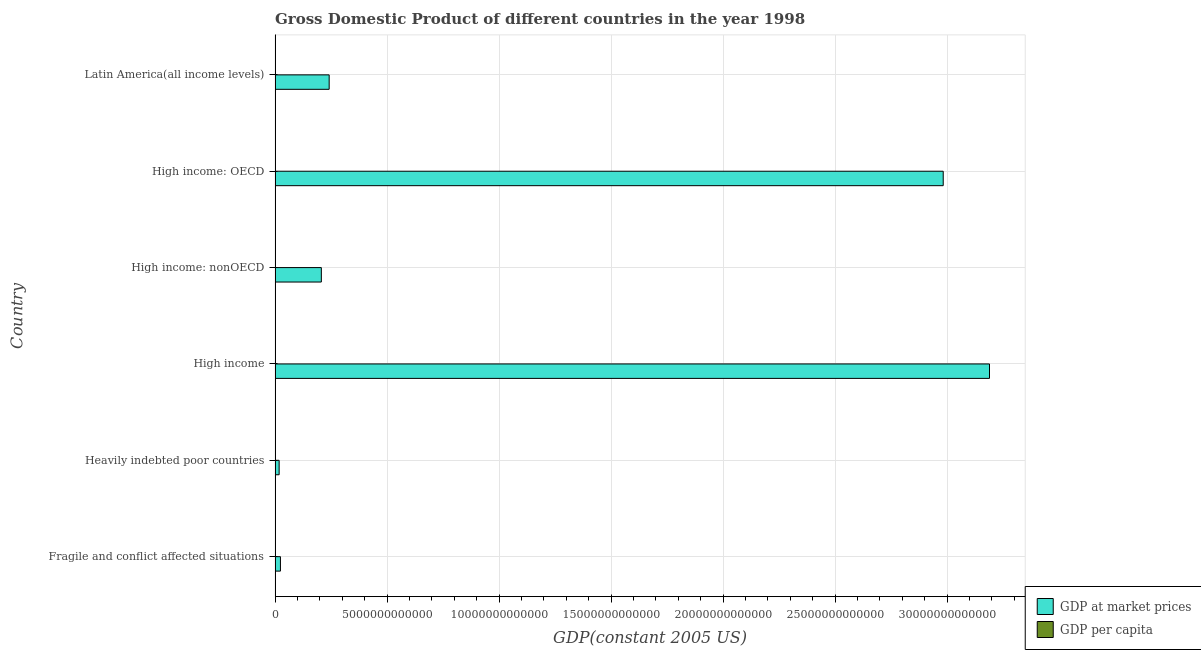Are the number of bars per tick equal to the number of legend labels?
Your answer should be very brief. Yes. How many bars are there on the 3rd tick from the top?
Keep it short and to the point. 2. How many bars are there on the 1st tick from the bottom?
Provide a short and direct response. 2. What is the label of the 1st group of bars from the top?
Offer a very short reply. Latin America(all income levels). In how many cases, is the number of bars for a given country not equal to the number of legend labels?
Provide a succinct answer. 0. What is the gdp at market prices in Fragile and conflict affected situations?
Your answer should be compact. 2.39e+11. Across all countries, what is the maximum gdp per capita?
Ensure brevity in your answer.  3.05e+04. Across all countries, what is the minimum gdp per capita?
Keep it short and to the point. 404.57. In which country was the gdp per capita maximum?
Give a very brief answer. High income: OECD. In which country was the gdp at market prices minimum?
Your response must be concise. Heavily indebted poor countries. What is the total gdp per capita in the graph?
Keep it short and to the point. 6.86e+04. What is the difference between the gdp per capita in Heavily indebted poor countries and that in High income: nonOECD?
Your response must be concise. -6675.54. What is the difference between the gdp at market prices in High income and the gdp per capita in High income: OECD?
Provide a short and direct response. 3.19e+13. What is the average gdp at market prices per country?
Provide a short and direct response. 1.11e+13. What is the difference between the gdp per capita and gdp at market prices in Fragile and conflict affected situations?
Ensure brevity in your answer.  -2.39e+11. In how many countries, is the gdp at market prices greater than 20000000000000 US$?
Your response must be concise. 2. What is the ratio of the gdp at market prices in Heavily indebted poor countries to that in Latin America(all income levels)?
Provide a succinct answer. 0.07. Is the difference between the gdp at market prices in High income: OECD and High income: nonOECD greater than the difference between the gdp per capita in High income: OECD and High income: nonOECD?
Offer a terse response. Yes. What is the difference between the highest and the second highest gdp at market prices?
Provide a short and direct response. 2.07e+12. What is the difference between the highest and the lowest gdp at market prices?
Your response must be concise. 3.17e+13. Is the sum of the gdp at market prices in Fragile and conflict affected situations and Latin America(all income levels) greater than the maximum gdp per capita across all countries?
Your answer should be very brief. Yes. What does the 1st bar from the top in Heavily indebted poor countries represents?
Keep it short and to the point. GDP per capita. What does the 1st bar from the bottom in High income represents?
Provide a short and direct response. GDP at market prices. How many bars are there?
Provide a short and direct response. 12. Are all the bars in the graph horizontal?
Provide a short and direct response. Yes. What is the difference between two consecutive major ticks on the X-axis?
Your answer should be compact. 5.00e+12. Are the values on the major ticks of X-axis written in scientific E-notation?
Provide a succinct answer. No. Does the graph contain any zero values?
Provide a succinct answer. No. Where does the legend appear in the graph?
Your response must be concise. Bottom right. How many legend labels are there?
Your answer should be compact. 2. How are the legend labels stacked?
Your answer should be compact. Vertical. What is the title of the graph?
Make the answer very short. Gross Domestic Product of different countries in the year 1998. What is the label or title of the X-axis?
Give a very brief answer. GDP(constant 2005 US). What is the label or title of the Y-axis?
Offer a very short reply. Country. What is the GDP(constant 2005 US) of GDP at market prices in Fragile and conflict affected situations?
Your answer should be very brief. 2.39e+11. What is the GDP(constant 2005 US) of GDP per capita in Fragile and conflict affected situations?
Make the answer very short. 747.77. What is the GDP(constant 2005 US) of GDP at market prices in Heavily indebted poor countries?
Make the answer very short. 1.82e+11. What is the GDP(constant 2005 US) of GDP per capita in Heavily indebted poor countries?
Keep it short and to the point. 404.57. What is the GDP(constant 2005 US) of GDP at market prices in High income?
Keep it short and to the point. 3.19e+13. What is the GDP(constant 2005 US) of GDP per capita in High income?
Make the answer very short. 2.51e+04. What is the GDP(constant 2005 US) of GDP at market prices in High income: nonOECD?
Offer a terse response. 2.07e+12. What is the GDP(constant 2005 US) of GDP per capita in High income: nonOECD?
Give a very brief answer. 7080.11. What is the GDP(constant 2005 US) of GDP at market prices in High income: OECD?
Make the answer very short. 2.98e+13. What is the GDP(constant 2005 US) of GDP per capita in High income: OECD?
Provide a succinct answer. 3.05e+04. What is the GDP(constant 2005 US) of GDP at market prices in Latin America(all income levels)?
Your answer should be very brief. 2.41e+12. What is the GDP(constant 2005 US) in GDP per capita in Latin America(all income levels)?
Your answer should be very brief. 4731.76. Across all countries, what is the maximum GDP(constant 2005 US) in GDP at market prices?
Offer a very short reply. 3.19e+13. Across all countries, what is the maximum GDP(constant 2005 US) of GDP per capita?
Provide a short and direct response. 3.05e+04. Across all countries, what is the minimum GDP(constant 2005 US) in GDP at market prices?
Offer a terse response. 1.82e+11. Across all countries, what is the minimum GDP(constant 2005 US) of GDP per capita?
Provide a succinct answer. 404.57. What is the total GDP(constant 2005 US) of GDP at market prices in the graph?
Your response must be concise. 6.66e+13. What is the total GDP(constant 2005 US) in GDP per capita in the graph?
Give a very brief answer. 6.86e+04. What is the difference between the GDP(constant 2005 US) in GDP at market prices in Fragile and conflict affected situations and that in Heavily indebted poor countries?
Provide a succinct answer. 5.77e+1. What is the difference between the GDP(constant 2005 US) of GDP per capita in Fragile and conflict affected situations and that in Heavily indebted poor countries?
Your response must be concise. 343.2. What is the difference between the GDP(constant 2005 US) in GDP at market prices in Fragile and conflict affected situations and that in High income?
Make the answer very short. -3.17e+13. What is the difference between the GDP(constant 2005 US) in GDP per capita in Fragile and conflict affected situations and that in High income?
Provide a succinct answer. -2.44e+04. What is the difference between the GDP(constant 2005 US) of GDP at market prices in Fragile and conflict affected situations and that in High income: nonOECD?
Offer a terse response. -1.83e+12. What is the difference between the GDP(constant 2005 US) in GDP per capita in Fragile and conflict affected situations and that in High income: nonOECD?
Offer a terse response. -6332.34. What is the difference between the GDP(constant 2005 US) of GDP at market prices in Fragile and conflict affected situations and that in High income: OECD?
Provide a short and direct response. -2.96e+13. What is the difference between the GDP(constant 2005 US) of GDP per capita in Fragile and conflict affected situations and that in High income: OECD?
Ensure brevity in your answer.  -2.98e+04. What is the difference between the GDP(constant 2005 US) of GDP at market prices in Fragile and conflict affected situations and that in Latin America(all income levels)?
Provide a short and direct response. -2.18e+12. What is the difference between the GDP(constant 2005 US) in GDP per capita in Fragile and conflict affected situations and that in Latin America(all income levels)?
Your answer should be very brief. -3983.99. What is the difference between the GDP(constant 2005 US) of GDP at market prices in Heavily indebted poor countries and that in High income?
Give a very brief answer. -3.17e+13. What is the difference between the GDP(constant 2005 US) of GDP per capita in Heavily indebted poor countries and that in High income?
Your answer should be very brief. -2.47e+04. What is the difference between the GDP(constant 2005 US) in GDP at market prices in Heavily indebted poor countries and that in High income: nonOECD?
Your answer should be compact. -1.88e+12. What is the difference between the GDP(constant 2005 US) in GDP per capita in Heavily indebted poor countries and that in High income: nonOECD?
Give a very brief answer. -6675.54. What is the difference between the GDP(constant 2005 US) of GDP at market prices in Heavily indebted poor countries and that in High income: OECD?
Make the answer very short. -2.96e+13. What is the difference between the GDP(constant 2005 US) in GDP per capita in Heavily indebted poor countries and that in High income: OECD?
Your answer should be compact. -3.01e+04. What is the difference between the GDP(constant 2005 US) of GDP at market prices in Heavily indebted poor countries and that in Latin America(all income levels)?
Make the answer very short. -2.23e+12. What is the difference between the GDP(constant 2005 US) of GDP per capita in Heavily indebted poor countries and that in Latin America(all income levels)?
Offer a terse response. -4327.18. What is the difference between the GDP(constant 2005 US) of GDP at market prices in High income and that in High income: nonOECD?
Your answer should be very brief. 2.98e+13. What is the difference between the GDP(constant 2005 US) in GDP per capita in High income and that in High income: nonOECD?
Give a very brief answer. 1.80e+04. What is the difference between the GDP(constant 2005 US) in GDP at market prices in High income and that in High income: OECD?
Offer a terse response. 2.07e+12. What is the difference between the GDP(constant 2005 US) of GDP per capita in High income and that in High income: OECD?
Your answer should be very brief. -5383.98. What is the difference between the GDP(constant 2005 US) of GDP at market prices in High income and that in Latin America(all income levels)?
Provide a succinct answer. 2.95e+13. What is the difference between the GDP(constant 2005 US) of GDP per capita in High income and that in Latin America(all income levels)?
Your response must be concise. 2.04e+04. What is the difference between the GDP(constant 2005 US) in GDP at market prices in High income: nonOECD and that in High income: OECD?
Keep it short and to the point. -2.78e+13. What is the difference between the GDP(constant 2005 US) of GDP per capita in High income: nonOECD and that in High income: OECD?
Offer a terse response. -2.34e+04. What is the difference between the GDP(constant 2005 US) in GDP at market prices in High income: nonOECD and that in Latin America(all income levels)?
Keep it short and to the point. -3.50e+11. What is the difference between the GDP(constant 2005 US) in GDP per capita in High income: nonOECD and that in Latin America(all income levels)?
Provide a succinct answer. 2348.35. What is the difference between the GDP(constant 2005 US) of GDP at market prices in High income: OECD and that in Latin America(all income levels)?
Make the answer very short. 2.74e+13. What is the difference between the GDP(constant 2005 US) of GDP per capita in High income: OECD and that in Latin America(all income levels)?
Offer a terse response. 2.58e+04. What is the difference between the GDP(constant 2005 US) of GDP at market prices in Fragile and conflict affected situations and the GDP(constant 2005 US) of GDP per capita in Heavily indebted poor countries?
Provide a short and direct response. 2.39e+11. What is the difference between the GDP(constant 2005 US) of GDP at market prices in Fragile and conflict affected situations and the GDP(constant 2005 US) of GDP per capita in High income?
Your answer should be very brief. 2.39e+11. What is the difference between the GDP(constant 2005 US) in GDP at market prices in Fragile and conflict affected situations and the GDP(constant 2005 US) in GDP per capita in High income: nonOECD?
Give a very brief answer. 2.39e+11. What is the difference between the GDP(constant 2005 US) in GDP at market prices in Fragile and conflict affected situations and the GDP(constant 2005 US) in GDP per capita in High income: OECD?
Provide a short and direct response. 2.39e+11. What is the difference between the GDP(constant 2005 US) in GDP at market prices in Fragile and conflict affected situations and the GDP(constant 2005 US) in GDP per capita in Latin America(all income levels)?
Give a very brief answer. 2.39e+11. What is the difference between the GDP(constant 2005 US) of GDP at market prices in Heavily indebted poor countries and the GDP(constant 2005 US) of GDP per capita in High income?
Your response must be concise. 1.82e+11. What is the difference between the GDP(constant 2005 US) of GDP at market prices in Heavily indebted poor countries and the GDP(constant 2005 US) of GDP per capita in High income: nonOECD?
Give a very brief answer. 1.82e+11. What is the difference between the GDP(constant 2005 US) in GDP at market prices in Heavily indebted poor countries and the GDP(constant 2005 US) in GDP per capita in High income: OECD?
Make the answer very short. 1.82e+11. What is the difference between the GDP(constant 2005 US) in GDP at market prices in Heavily indebted poor countries and the GDP(constant 2005 US) in GDP per capita in Latin America(all income levels)?
Keep it short and to the point. 1.82e+11. What is the difference between the GDP(constant 2005 US) in GDP at market prices in High income and the GDP(constant 2005 US) in GDP per capita in High income: nonOECD?
Your response must be concise. 3.19e+13. What is the difference between the GDP(constant 2005 US) of GDP at market prices in High income and the GDP(constant 2005 US) of GDP per capita in High income: OECD?
Make the answer very short. 3.19e+13. What is the difference between the GDP(constant 2005 US) of GDP at market prices in High income and the GDP(constant 2005 US) of GDP per capita in Latin America(all income levels)?
Your answer should be very brief. 3.19e+13. What is the difference between the GDP(constant 2005 US) of GDP at market prices in High income: nonOECD and the GDP(constant 2005 US) of GDP per capita in High income: OECD?
Provide a succinct answer. 2.07e+12. What is the difference between the GDP(constant 2005 US) of GDP at market prices in High income: nonOECD and the GDP(constant 2005 US) of GDP per capita in Latin America(all income levels)?
Provide a short and direct response. 2.07e+12. What is the difference between the GDP(constant 2005 US) of GDP at market prices in High income: OECD and the GDP(constant 2005 US) of GDP per capita in Latin America(all income levels)?
Provide a short and direct response. 2.98e+13. What is the average GDP(constant 2005 US) of GDP at market prices per country?
Make the answer very short. 1.11e+13. What is the average GDP(constant 2005 US) in GDP per capita per country?
Your response must be concise. 1.14e+04. What is the difference between the GDP(constant 2005 US) in GDP at market prices and GDP(constant 2005 US) in GDP per capita in Fragile and conflict affected situations?
Ensure brevity in your answer.  2.39e+11. What is the difference between the GDP(constant 2005 US) in GDP at market prices and GDP(constant 2005 US) in GDP per capita in Heavily indebted poor countries?
Offer a terse response. 1.82e+11. What is the difference between the GDP(constant 2005 US) of GDP at market prices and GDP(constant 2005 US) of GDP per capita in High income?
Your answer should be compact. 3.19e+13. What is the difference between the GDP(constant 2005 US) in GDP at market prices and GDP(constant 2005 US) in GDP per capita in High income: nonOECD?
Your answer should be compact. 2.07e+12. What is the difference between the GDP(constant 2005 US) in GDP at market prices and GDP(constant 2005 US) in GDP per capita in High income: OECD?
Your answer should be compact. 2.98e+13. What is the difference between the GDP(constant 2005 US) of GDP at market prices and GDP(constant 2005 US) of GDP per capita in Latin America(all income levels)?
Keep it short and to the point. 2.41e+12. What is the ratio of the GDP(constant 2005 US) of GDP at market prices in Fragile and conflict affected situations to that in Heavily indebted poor countries?
Ensure brevity in your answer.  1.32. What is the ratio of the GDP(constant 2005 US) of GDP per capita in Fragile and conflict affected situations to that in Heavily indebted poor countries?
Make the answer very short. 1.85. What is the ratio of the GDP(constant 2005 US) of GDP at market prices in Fragile and conflict affected situations to that in High income?
Your answer should be compact. 0.01. What is the ratio of the GDP(constant 2005 US) in GDP per capita in Fragile and conflict affected situations to that in High income?
Give a very brief answer. 0.03. What is the ratio of the GDP(constant 2005 US) of GDP at market prices in Fragile and conflict affected situations to that in High income: nonOECD?
Make the answer very short. 0.12. What is the ratio of the GDP(constant 2005 US) of GDP per capita in Fragile and conflict affected situations to that in High income: nonOECD?
Your answer should be compact. 0.11. What is the ratio of the GDP(constant 2005 US) of GDP at market prices in Fragile and conflict affected situations to that in High income: OECD?
Offer a very short reply. 0.01. What is the ratio of the GDP(constant 2005 US) of GDP per capita in Fragile and conflict affected situations to that in High income: OECD?
Make the answer very short. 0.02. What is the ratio of the GDP(constant 2005 US) in GDP at market prices in Fragile and conflict affected situations to that in Latin America(all income levels)?
Make the answer very short. 0.1. What is the ratio of the GDP(constant 2005 US) in GDP per capita in Fragile and conflict affected situations to that in Latin America(all income levels)?
Offer a terse response. 0.16. What is the ratio of the GDP(constant 2005 US) in GDP at market prices in Heavily indebted poor countries to that in High income?
Keep it short and to the point. 0.01. What is the ratio of the GDP(constant 2005 US) in GDP per capita in Heavily indebted poor countries to that in High income?
Give a very brief answer. 0.02. What is the ratio of the GDP(constant 2005 US) in GDP at market prices in Heavily indebted poor countries to that in High income: nonOECD?
Offer a very short reply. 0.09. What is the ratio of the GDP(constant 2005 US) of GDP per capita in Heavily indebted poor countries to that in High income: nonOECD?
Your response must be concise. 0.06. What is the ratio of the GDP(constant 2005 US) of GDP at market prices in Heavily indebted poor countries to that in High income: OECD?
Your answer should be compact. 0.01. What is the ratio of the GDP(constant 2005 US) in GDP per capita in Heavily indebted poor countries to that in High income: OECD?
Offer a terse response. 0.01. What is the ratio of the GDP(constant 2005 US) in GDP at market prices in Heavily indebted poor countries to that in Latin America(all income levels)?
Keep it short and to the point. 0.08. What is the ratio of the GDP(constant 2005 US) of GDP per capita in Heavily indebted poor countries to that in Latin America(all income levels)?
Provide a short and direct response. 0.09. What is the ratio of the GDP(constant 2005 US) of GDP at market prices in High income to that in High income: nonOECD?
Give a very brief answer. 15.44. What is the ratio of the GDP(constant 2005 US) in GDP per capita in High income to that in High income: nonOECD?
Your response must be concise. 3.55. What is the ratio of the GDP(constant 2005 US) of GDP at market prices in High income to that in High income: OECD?
Make the answer very short. 1.07. What is the ratio of the GDP(constant 2005 US) in GDP per capita in High income to that in High income: OECD?
Keep it short and to the point. 0.82. What is the ratio of the GDP(constant 2005 US) in GDP at market prices in High income to that in Latin America(all income levels)?
Your response must be concise. 13.21. What is the ratio of the GDP(constant 2005 US) of GDP per capita in High income to that in Latin America(all income levels)?
Keep it short and to the point. 5.31. What is the ratio of the GDP(constant 2005 US) of GDP at market prices in High income: nonOECD to that in High income: OECD?
Your answer should be compact. 0.07. What is the ratio of the GDP(constant 2005 US) in GDP per capita in High income: nonOECD to that in High income: OECD?
Offer a very short reply. 0.23. What is the ratio of the GDP(constant 2005 US) of GDP at market prices in High income: nonOECD to that in Latin America(all income levels)?
Your response must be concise. 0.86. What is the ratio of the GDP(constant 2005 US) of GDP per capita in High income: nonOECD to that in Latin America(all income levels)?
Provide a succinct answer. 1.5. What is the ratio of the GDP(constant 2005 US) of GDP at market prices in High income: OECD to that in Latin America(all income levels)?
Your answer should be compact. 12.35. What is the ratio of the GDP(constant 2005 US) in GDP per capita in High income: OECD to that in Latin America(all income levels)?
Ensure brevity in your answer.  6.45. What is the difference between the highest and the second highest GDP(constant 2005 US) in GDP at market prices?
Keep it short and to the point. 2.07e+12. What is the difference between the highest and the second highest GDP(constant 2005 US) of GDP per capita?
Your answer should be very brief. 5383.98. What is the difference between the highest and the lowest GDP(constant 2005 US) of GDP at market prices?
Keep it short and to the point. 3.17e+13. What is the difference between the highest and the lowest GDP(constant 2005 US) in GDP per capita?
Your answer should be compact. 3.01e+04. 